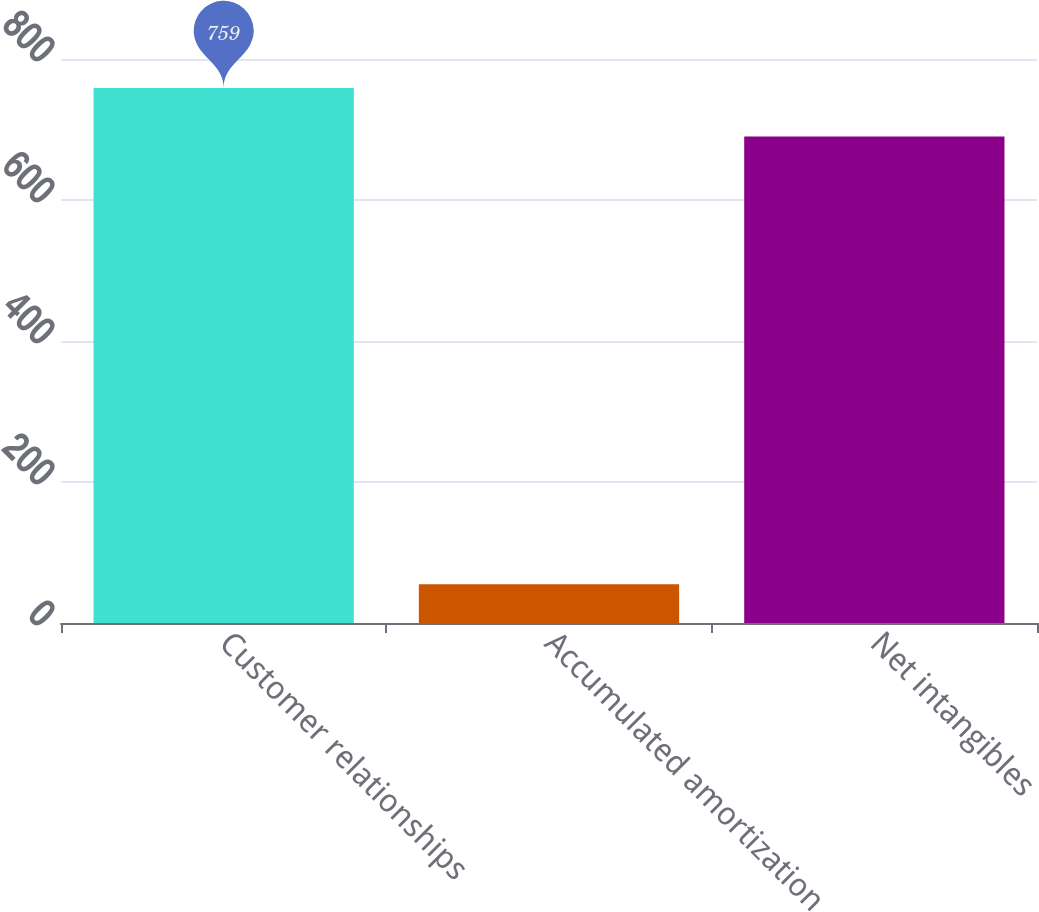Convert chart. <chart><loc_0><loc_0><loc_500><loc_500><bar_chart><fcel>Customer relationships<fcel>Accumulated amortization<fcel>Net intangibles<nl><fcel>759<fcel>55<fcel>690<nl></chart> 